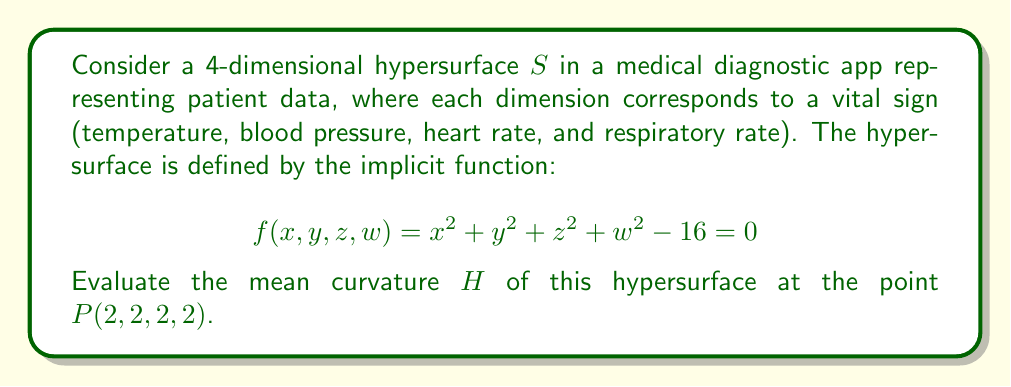Help me with this question. To evaluate the mean curvature of the hypersurface, we'll follow these steps:

1) The mean curvature $H$ of a hypersurface in 4D space is given by:

   $$H = \frac{1}{4} \text{div}\left(\frac{\nabla f}{|\nabla f|}\right)$$

2) First, let's calculate $\nabla f$:
   $$\nabla f = (2x, 2y, 2z, 2w)$$

3) At point $P(2,2,2,2)$:
   $$\nabla f|_P = (4, 4, 4, 4)$$

4) Calculate $|\nabla f|$ at $P$:
   $$|\nabla f|_P = \sqrt{4^2 + 4^2 + 4^2 + 4^2} = 8$$

5) Now, we need to calculate $\text{div}\left(\frac{\nabla f}{|\nabla f|}\right)$:

   $$\frac{\nabla f}{|\nabla f|} = \left(\frac{x}{4}, \frac{y}{4}, \frac{z}{4}, \frac{w}{4}\right)$$

6) The divergence of this vector field is:

   $$\text{div}\left(\frac{\nabla f}{|\nabla f|}\right) = \frac{\partial}{\partial x}\left(\frac{x}{4}\right) + \frac{\partial}{\partial y}\left(\frac{y}{4}\right) + \frac{\partial}{\partial z}\left(\frac{z}{4}\right) + \frac{\partial}{\partial w}\left(\frac{w}{4}\right) = \frac{1}{4} + \frac{1}{4} + \frac{1}{4} + \frac{1}{4} = 1$$

7) Finally, we can calculate the mean curvature:

   $$H = \frac{1}{4} \cdot 1 = \frac{1}{4}$$

Therefore, the mean curvature of the hypersurface at point $P(2,2,2,2)$ is $\frac{1}{4}$.
Answer: $\frac{1}{4}$ 